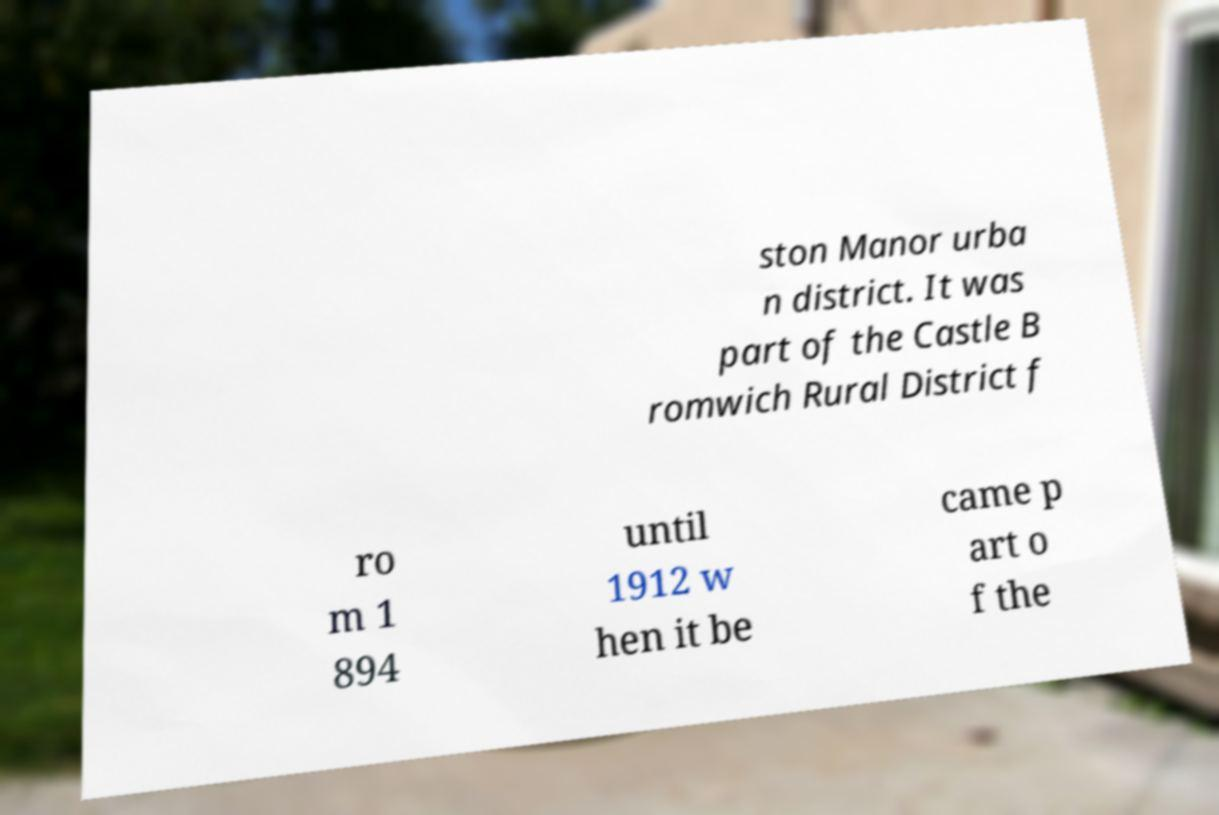What messages or text are displayed in this image? I need them in a readable, typed format. ston Manor urba n district. It was part of the Castle B romwich Rural District f ro m 1 894 until 1912 w hen it be came p art o f the 